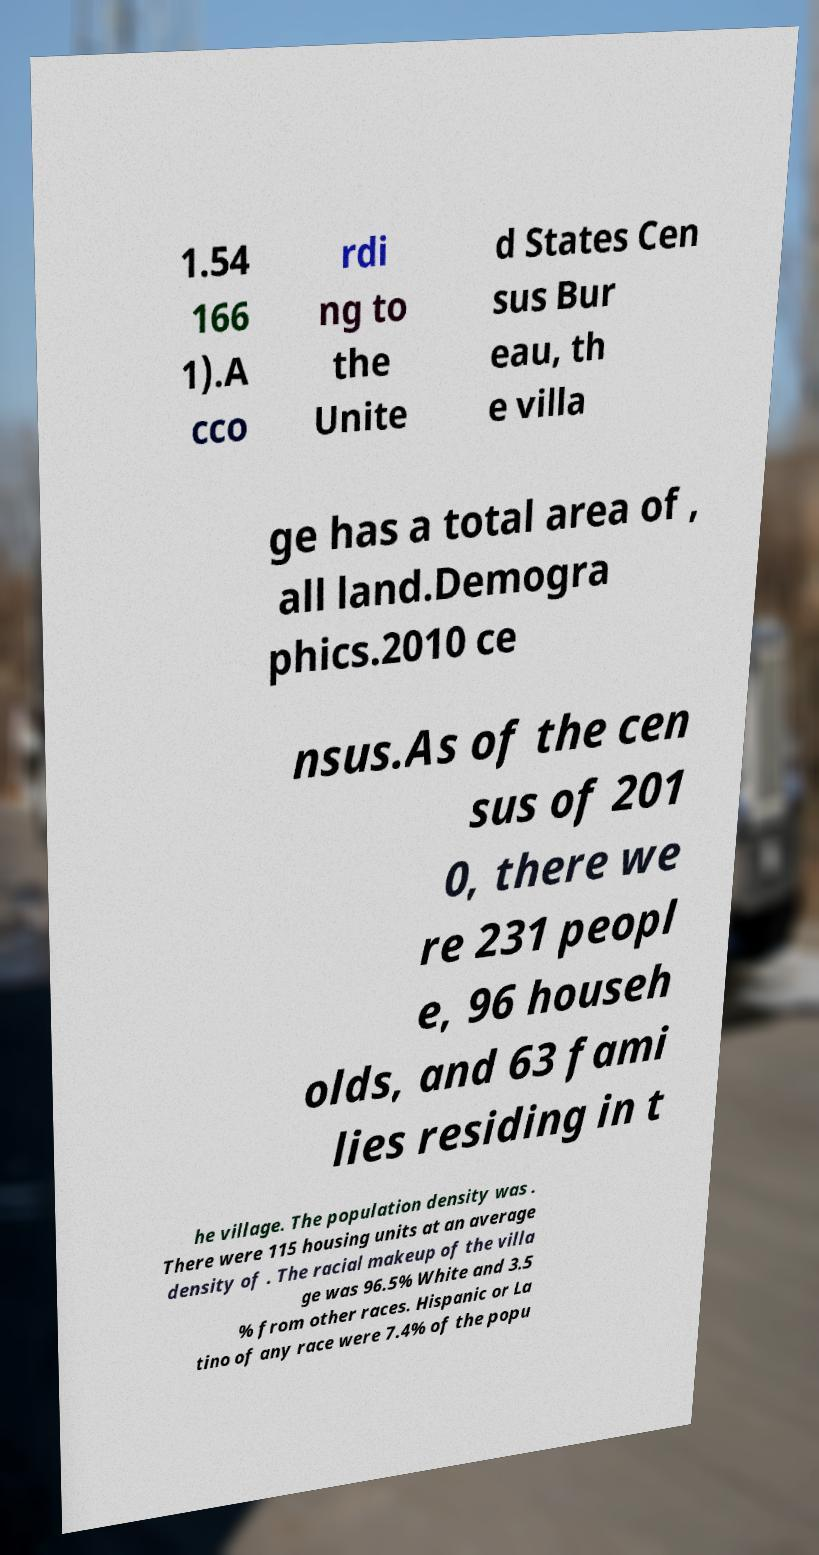Can you read and provide the text displayed in the image?This photo seems to have some interesting text. Can you extract and type it out for me? 1.54 166 1).A cco rdi ng to the Unite d States Cen sus Bur eau, th e villa ge has a total area of , all land.Demogra phics.2010 ce nsus.As of the cen sus of 201 0, there we re 231 peopl e, 96 househ olds, and 63 fami lies residing in t he village. The population density was . There were 115 housing units at an average density of . The racial makeup of the villa ge was 96.5% White and 3.5 % from other races. Hispanic or La tino of any race were 7.4% of the popu 